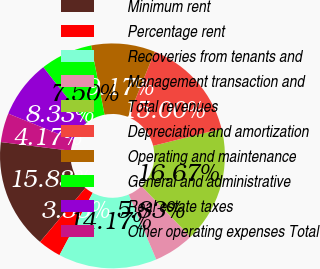<chart> <loc_0><loc_0><loc_500><loc_500><pie_chart><fcel>Minimum rent<fcel>Percentage rent<fcel>Recoveries from tenants and<fcel>Management transaction and<fcel>Total revenues<fcel>Depreciation and amortization<fcel>Operating and maintenance<fcel>General and administrative<fcel>Real estate taxes<fcel>Other operating expenses Total<nl><fcel>15.83%<fcel>3.33%<fcel>14.17%<fcel>5.83%<fcel>16.67%<fcel>15.0%<fcel>9.17%<fcel>7.5%<fcel>8.33%<fcel>4.17%<nl></chart> 